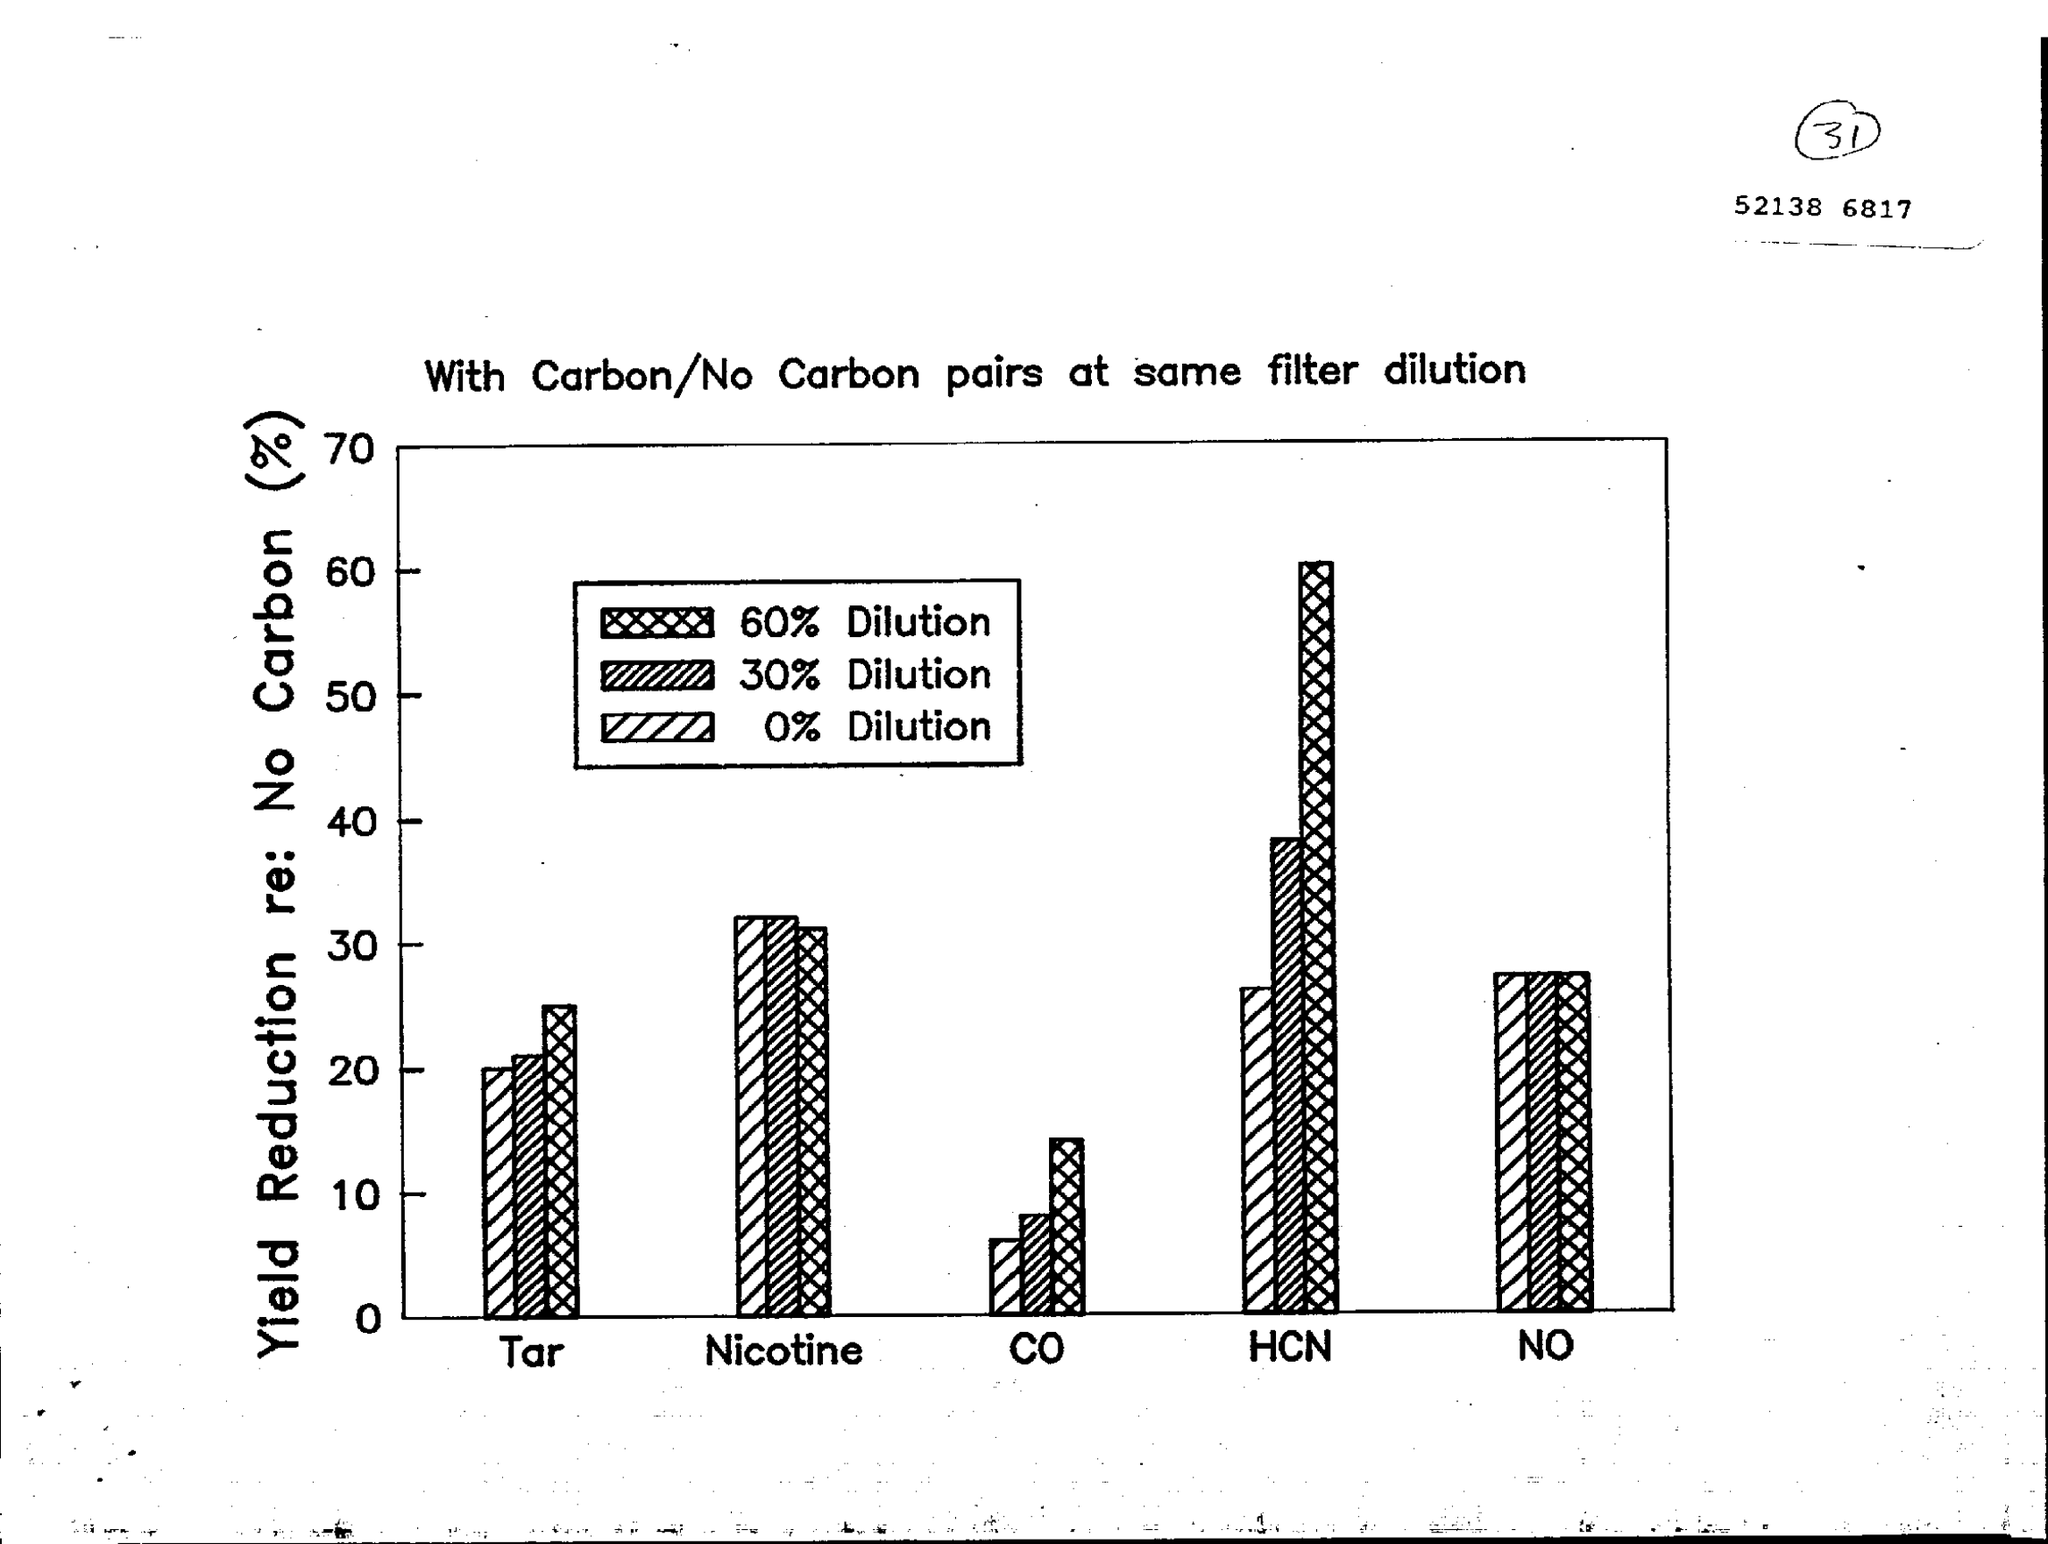What is the variable on Y axis of the bar chart?
Your response must be concise. Yield reduction re: no carbon (%). 